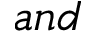<formula> <loc_0><loc_0><loc_500><loc_500>a n d</formula> 